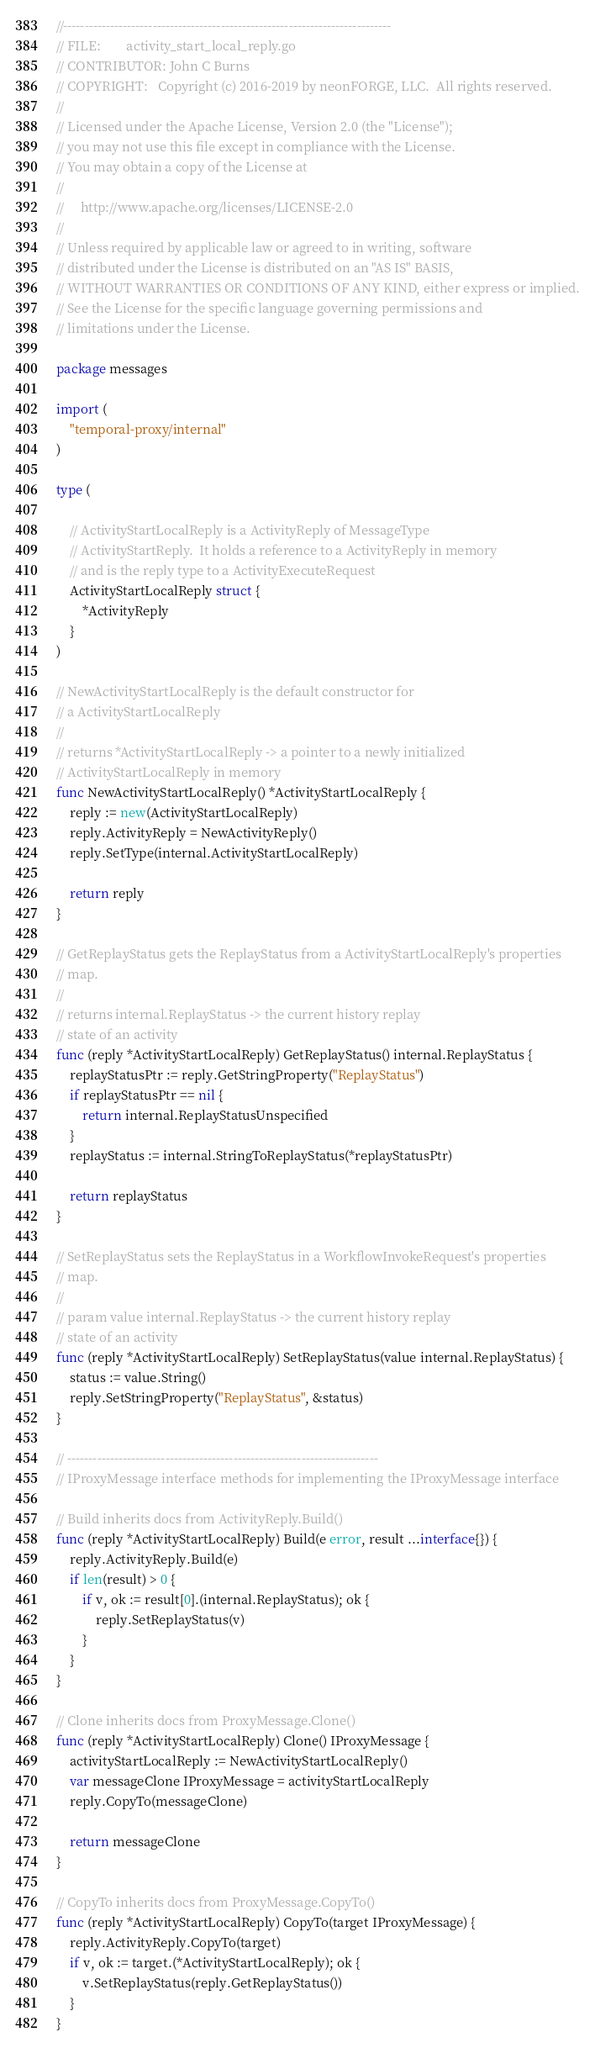<code> <loc_0><loc_0><loc_500><loc_500><_Go_>//-----------------------------------------------------------------------------
// FILE:		activity_start_local_reply.go
// CONTRIBUTOR: John C Burns
// COPYRIGHT:	Copyright (c) 2016-2019 by neonFORGE, LLC.  All rights reserved.
//
// Licensed under the Apache License, Version 2.0 (the "License");
// you may not use this file except in compliance with the License.
// You may obtain a copy of the License at
//
//     http://www.apache.org/licenses/LICENSE-2.0
//
// Unless required by applicable law or agreed to in writing, software
// distributed under the License is distributed on an "AS IS" BASIS,
// WITHOUT WARRANTIES OR CONDITIONS OF ANY KIND, either express or implied.
// See the License for the specific language governing permissions and
// limitations under the License.

package messages

import (
	"temporal-proxy/internal"
)

type (

	// ActivityStartLocalReply is a ActivityReply of MessageType
	// ActivityStartReply.  It holds a reference to a ActivityReply in memory
	// and is the reply type to a ActivityExecuteRequest
	ActivityStartLocalReply struct {
		*ActivityReply
	}
)

// NewActivityStartLocalReply is the default constructor for
// a ActivityStartLocalReply
//
// returns *ActivityStartLocalReply -> a pointer to a newly initialized
// ActivityStartLocalReply in memory
func NewActivityStartLocalReply() *ActivityStartLocalReply {
	reply := new(ActivityStartLocalReply)
	reply.ActivityReply = NewActivityReply()
	reply.SetType(internal.ActivityStartLocalReply)

	return reply
}

// GetReplayStatus gets the ReplayStatus from a ActivityStartLocalReply's properties
// map.
//
// returns internal.ReplayStatus -> the current history replay
// state of an activity
func (reply *ActivityStartLocalReply) GetReplayStatus() internal.ReplayStatus {
	replayStatusPtr := reply.GetStringProperty("ReplayStatus")
	if replayStatusPtr == nil {
		return internal.ReplayStatusUnspecified
	}
	replayStatus := internal.StringToReplayStatus(*replayStatusPtr)

	return replayStatus
}

// SetReplayStatus sets the ReplayStatus in a WorkflowInvokeRequest's properties
// map.
//
// param value internal.ReplayStatus -> the current history replay
// state of an activity
func (reply *ActivityStartLocalReply) SetReplayStatus(value internal.ReplayStatus) {
	status := value.String()
	reply.SetStringProperty("ReplayStatus", &status)
}

// -------------------------------------------------------------------------
// IProxyMessage interface methods for implementing the IProxyMessage interface

// Build inherits docs from ActivityReply.Build()
func (reply *ActivityStartLocalReply) Build(e error, result ...interface{}) {
	reply.ActivityReply.Build(e)
	if len(result) > 0 {
		if v, ok := result[0].(internal.ReplayStatus); ok {
			reply.SetReplayStatus(v)
		}
	}
}

// Clone inherits docs from ProxyMessage.Clone()
func (reply *ActivityStartLocalReply) Clone() IProxyMessage {
	activityStartLocalReply := NewActivityStartLocalReply()
	var messageClone IProxyMessage = activityStartLocalReply
	reply.CopyTo(messageClone)

	return messageClone
}

// CopyTo inherits docs from ProxyMessage.CopyTo()
func (reply *ActivityStartLocalReply) CopyTo(target IProxyMessage) {
	reply.ActivityReply.CopyTo(target)
	if v, ok := target.(*ActivityStartLocalReply); ok {
		v.SetReplayStatus(reply.GetReplayStatus())
	}
}
</code> 